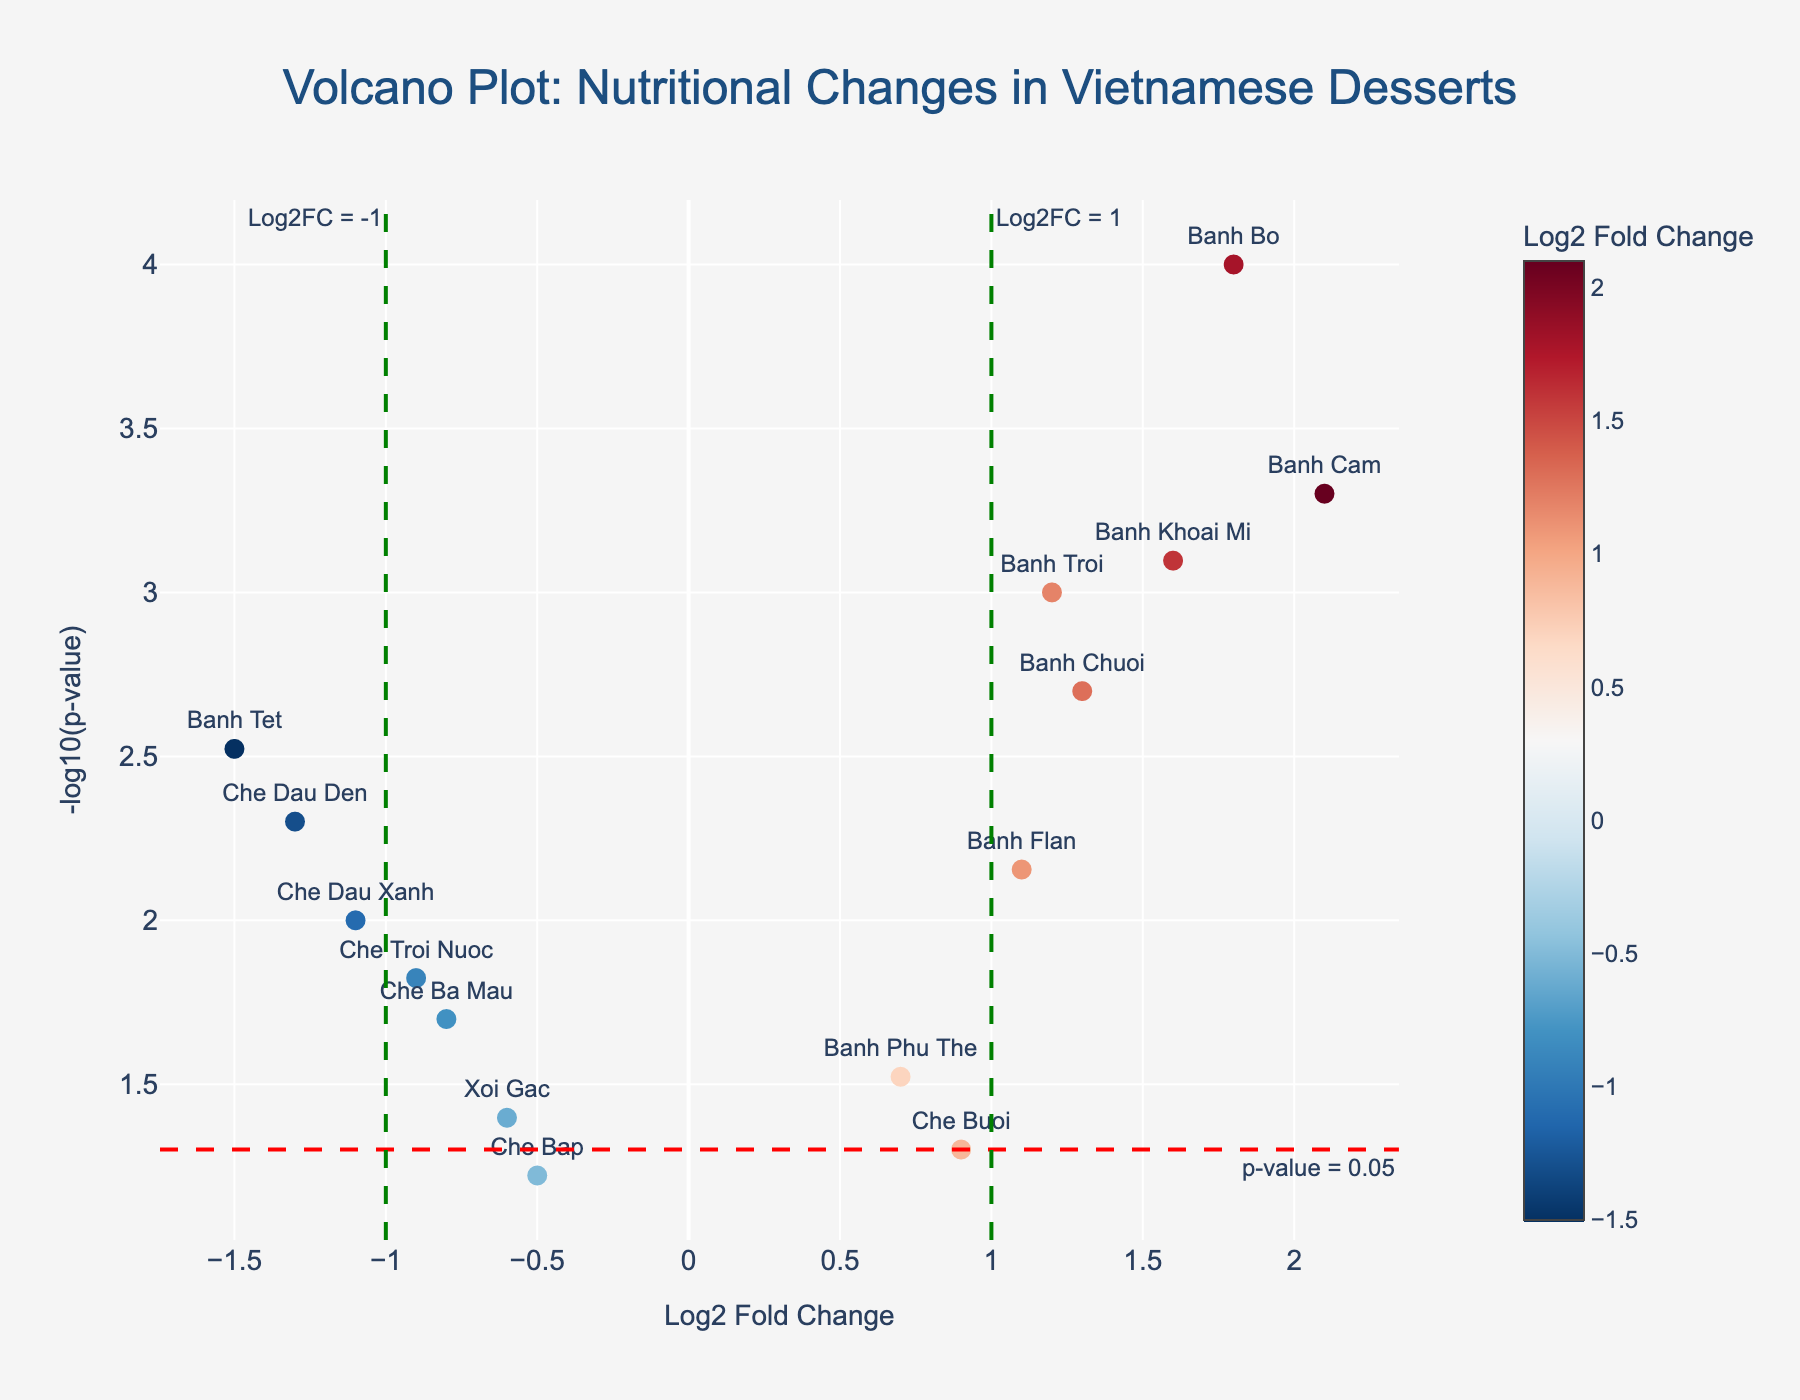How many data points are represented in the plot? Count the number of markers displayed in the plot, each representing a data point. There are 15 traditional Vietnamese desserts listed in the data table.
Answer: 15 What does a data point with a Log2 Fold Change above 1 and a p-value below 0.05 indicate? According to the plot, a Log2 Fold Change above 1 suggests that the nutritional content increased significantly after baking, and a p-value below 0.05 means this increase is statistically significant.
Answer: Significant increase Which dessert had the highest increase in nutritional content after baking, according to the plot? The highest Log2 Fold Change represents the greatest increase. Identify the point with the highest Log2 Fold Change value. Banh Cam has the highest Log2 Fold Change value of 2.1.
Answer: Banh Cam How does "Che Ba Mau" compare to "Che Buoi" in terms of nutritional content change and statistical significance? Compare the Log2 Fold Change and -log10(p-value) between the two data points. Che Ba Mau has a Log2 Fold Change of -0.8 and a p-value of 0.02, while Che Buoi has a Log2 Fold Change of 0.9 and a p-value of 0.05. Thus, Che Ba Mau decreased significantly, while Che Buoi increased slightly but not significantly.
Answer: Che Ba Mau decreased significantly; Che Buoi increased slightly What is the significance threshold for distinguishing significant changes in nutritional content? The plot includes a horizontal line at -log10(p-value) = -log10(0.05), marking the significance threshold.
Answer: p-value < 0.05 Which desserts experienced a significant decrease in nutritional content after baking? Look for data points with a Log2 Fold Change below -1 and a -log10(p-value) above the threshold line. Banh Tet and Che Dau Den satisfy these conditions.
Answer: Banh Tet, Che Dau Den What is the fold change and p-value for Banh Troi? Refer to the data table to find the values for Banh Troi. It has a Log2 Fold Change of 1.2 and a p-value of 0.001.
Answer: 1.2, 0.001 How many desserts show an increase in nutritional content but are not statistically significant? Count the points with a Log2 Fold Change above 0 but with a -log10(p-value) below the threshold line. Che Buoi and Banh Phu The fall into this category.
Answer: 2 desserts 